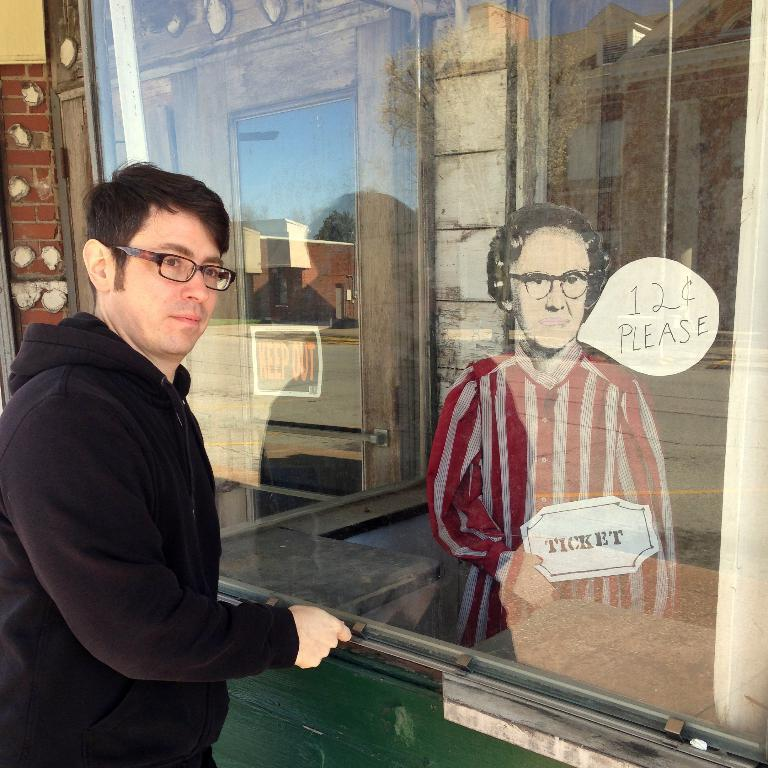What is the main subject of the image? There is a person in the image. What is the person doing in the image? The person is standing in the image. What is located behind the person? There is a glass behind the person. What object is beside the glass? There is a doll beside the glass. What type of curve can be seen in the person's brain in the image? There is no indication of the person's brain in the image, and therefore no curves can be observed. 